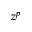Convert formula to latex. <formula><loc_0><loc_0><loc_500><loc_500>z ^ { p }</formula> 